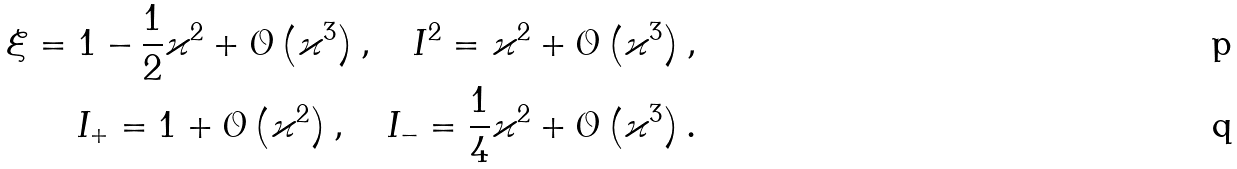Convert formula to latex. <formula><loc_0><loc_0><loc_500><loc_500>\xi = 1 - \frac { 1 } { 2 } \varkappa ^ { 2 } + \mathcal { O } \left ( \varkappa ^ { 3 } \right ) , \quad I ^ { 2 } = \varkappa ^ { 2 } + \mathcal { O } \left ( \varkappa ^ { 3 } \right ) , \\ I _ { + } = 1 + \mathcal { O } \left ( \varkappa ^ { 2 } \right ) , \quad I _ { - } = \frac { 1 } { 4 } \varkappa ^ { 2 } + \mathcal { O } \left ( \varkappa ^ { 3 } \right ) .</formula> 